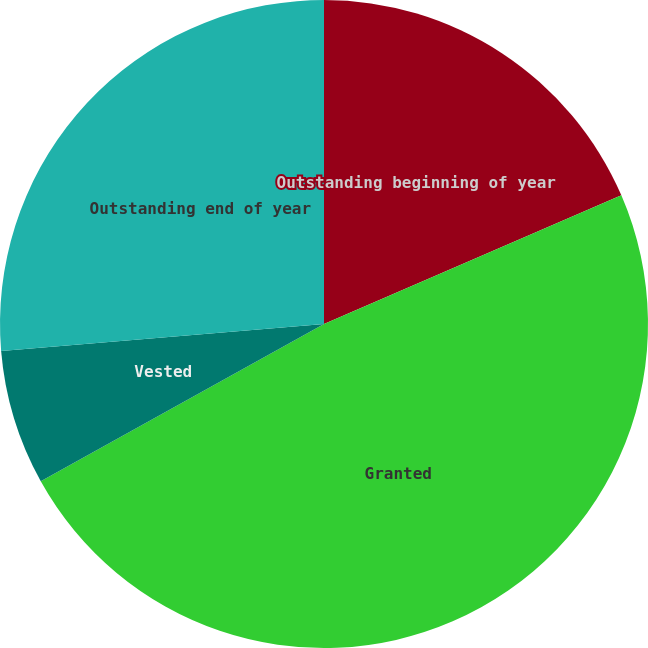<chart> <loc_0><loc_0><loc_500><loc_500><pie_chart><fcel>Outstanding beginning of year<fcel>Granted<fcel>Vested<fcel>Outstanding end of year<nl><fcel>18.5%<fcel>48.43%<fcel>6.74%<fcel>26.33%<nl></chart> 